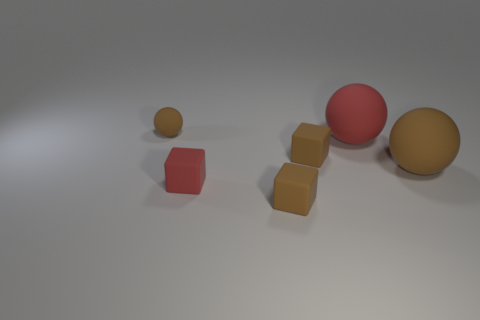What shape is the large brown rubber object?
Offer a terse response. Sphere. What number of small red things are the same shape as the big red object?
Offer a very short reply. 0. How many small brown blocks are both behind the big brown sphere and in front of the large brown rubber thing?
Make the answer very short. 0. What is the color of the small ball?
Your answer should be compact. Brown. Are there any small brown spheres that have the same material as the large red sphere?
Your response must be concise. Yes. There is a brown matte sphere behind the rubber ball that is right of the big red ball; is there a brown matte block to the left of it?
Make the answer very short. No. There is a red matte ball; are there any red matte things right of it?
Your answer should be very brief. No. Is there a tiny object of the same color as the tiny rubber sphere?
Make the answer very short. Yes. How many small things are either red blocks or brown matte balls?
Make the answer very short. 2. Are the brown block behind the red block and the small brown sphere made of the same material?
Ensure brevity in your answer.  Yes. 